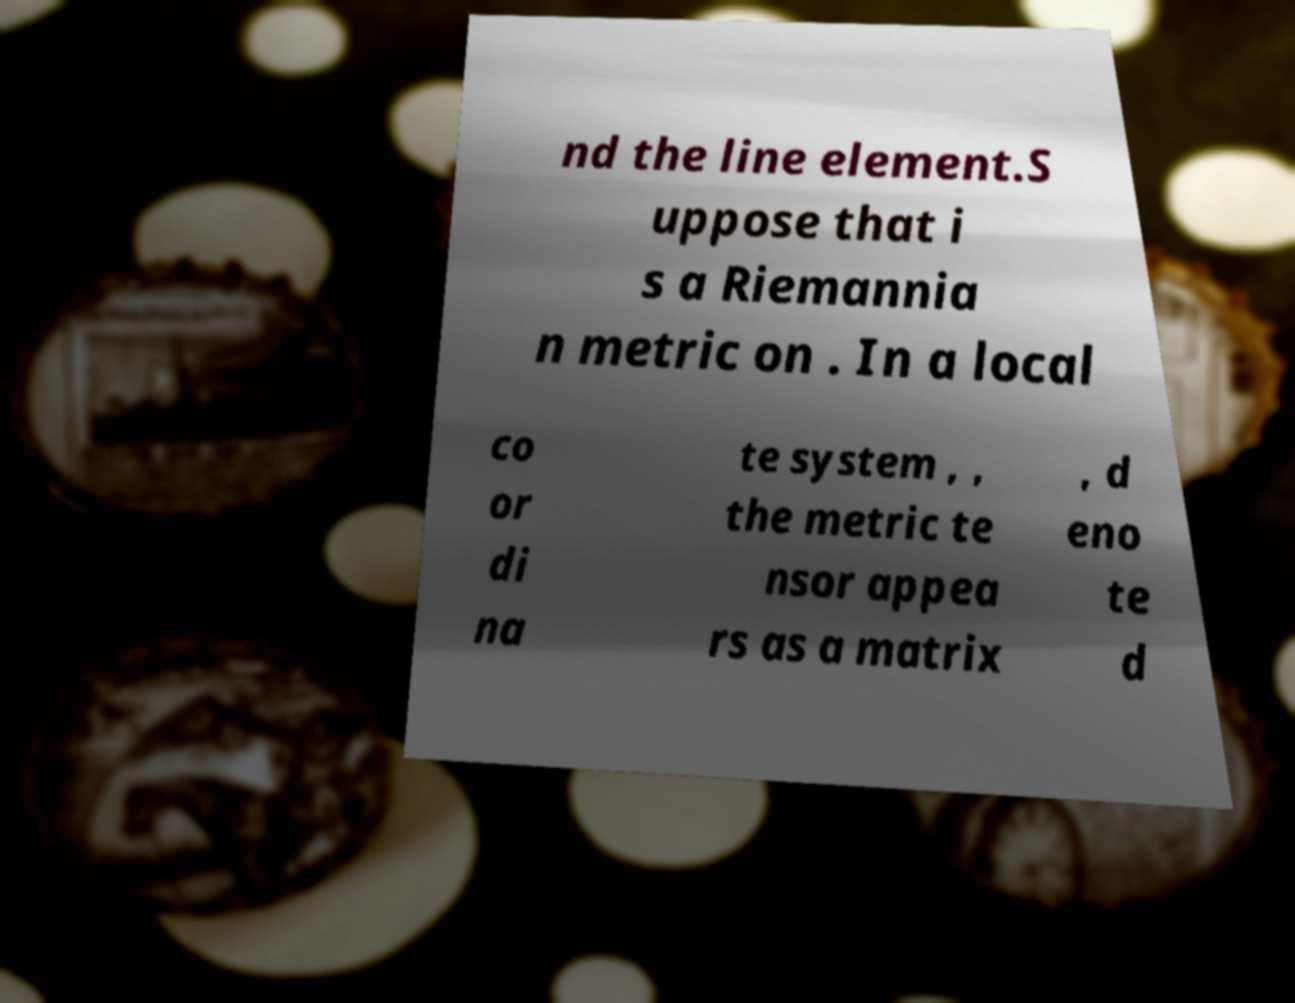Please read and relay the text visible in this image. What does it say? nd the line element.S uppose that i s a Riemannia n metric on . In a local co or di na te system , , the metric te nsor appea rs as a matrix , d eno te d 